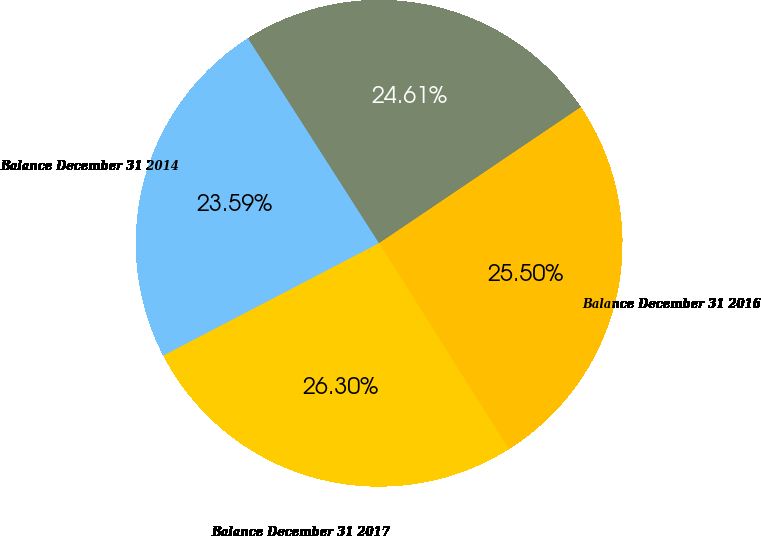Convert chart. <chart><loc_0><loc_0><loc_500><loc_500><pie_chart><fcel>Balance December 31 2014<fcel>Balance December 31 2015<fcel>Balance December 31 2016<fcel>Balance December 31 2017<nl><fcel>23.59%<fcel>24.61%<fcel>25.5%<fcel>26.3%<nl></chart> 